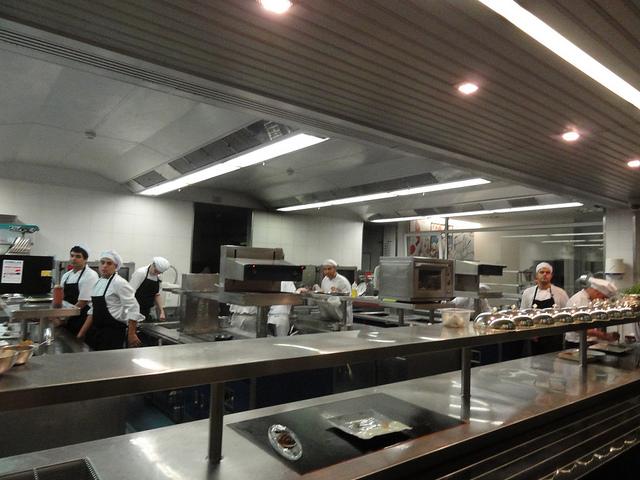Where is the picture taken?
Short answer required. Kitchen. What do these people do for work?
Write a very short answer. Cook. Is this photo from home?
Concise answer only. No. What color is the men wearing?
Concise answer only. White. Are you supposed to be loud or quiet here?
Keep it brief. Loud. 